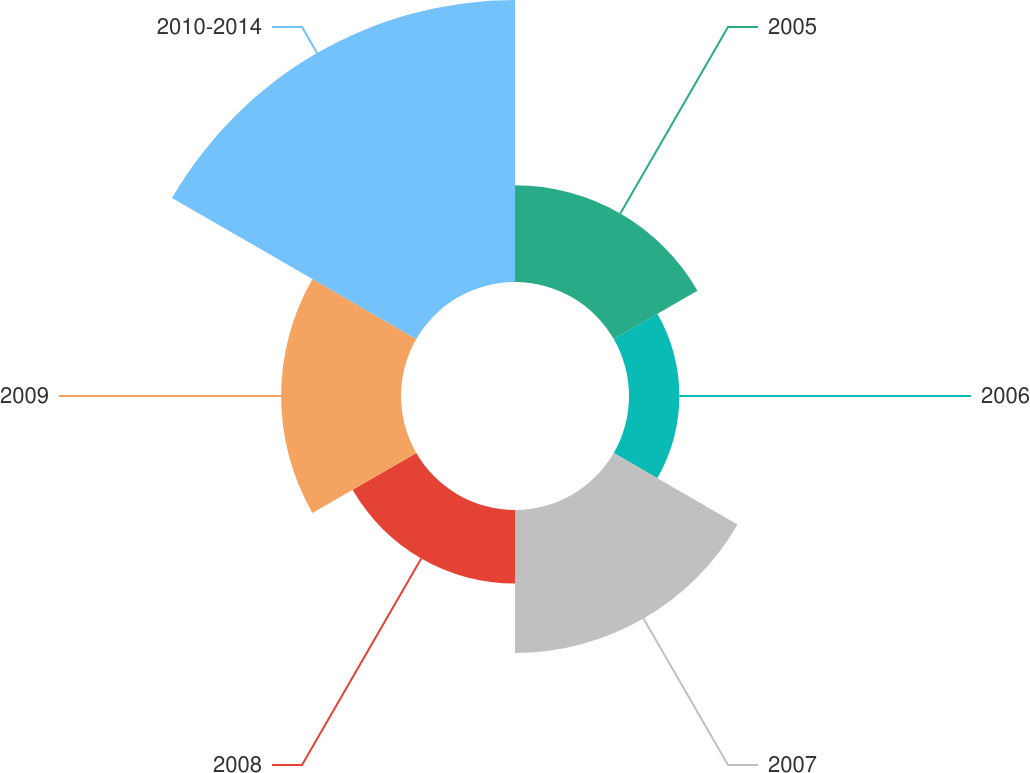Convert chart. <chart><loc_0><loc_0><loc_500><loc_500><pie_chart><fcel>2005<fcel>2006<fcel>2007<fcel>2008<fcel>2009<fcel>2010-2014<nl><fcel>12.63%<fcel>6.58%<fcel>18.68%<fcel>9.61%<fcel>15.66%<fcel>36.84%<nl></chart> 